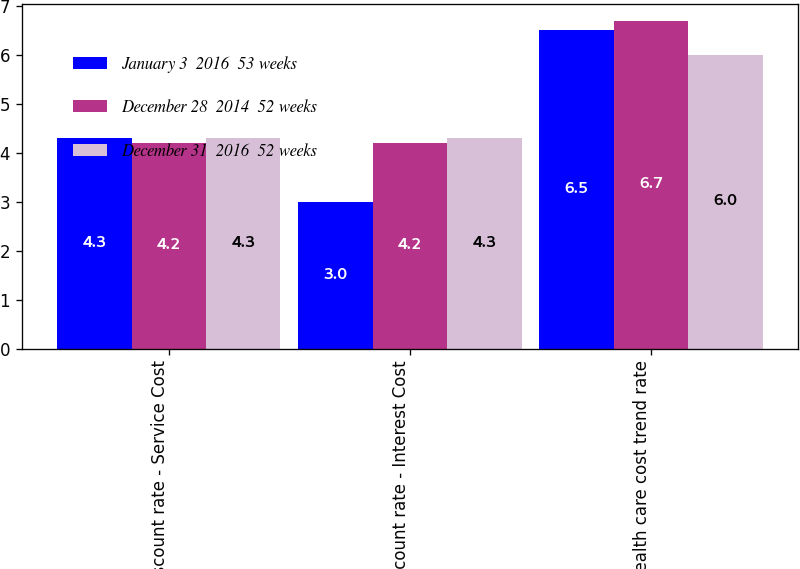Convert chart to OTSL. <chart><loc_0><loc_0><loc_500><loc_500><stacked_bar_chart><ecel><fcel>Discount rate - Service Cost<fcel>Discount rate - Interest Cost<fcel>Health care cost trend rate<nl><fcel>January 3  2016  53 weeks<fcel>4.3<fcel>3<fcel>6.5<nl><fcel>December 28  2014  52 weeks<fcel>4.2<fcel>4.2<fcel>6.7<nl><fcel>December 31  2016  52 weeks<fcel>4.3<fcel>4.3<fcel>6<nl></chart> 